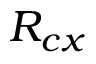Convert formula to latex. <formula><loc_0><loc_0><loc_500><loc_500>R _ { c x }</formula> 